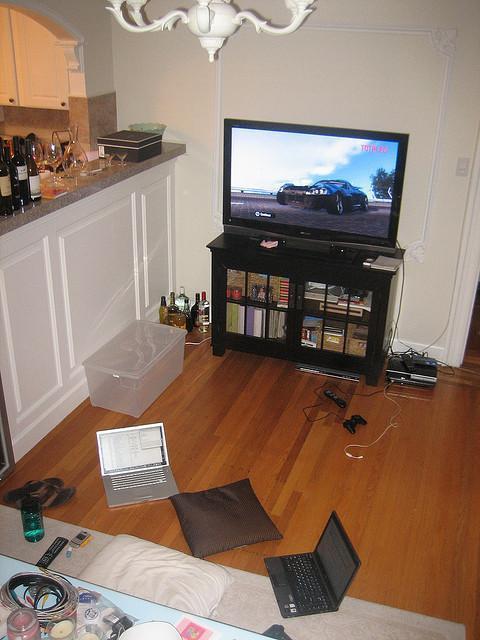How many laptops are visible?
Give a very brief answer. 2. 